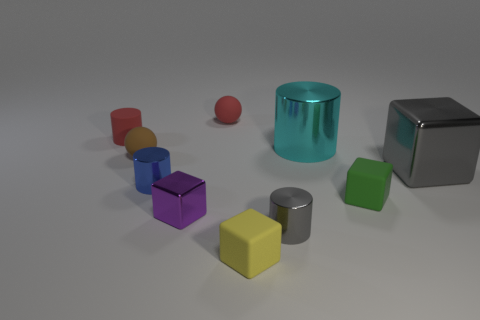Are there any cylinders on the right side of the brown thing?
Your response must be concise. Yes. What is the color of the rubber object that is both in front of the small blue object and behind the purple metal block?
Give a very brief answer. Green. Are there any small cylinders that have the same color as the large shiny cube?
Make the answer very short. Yes. Do the purple cube that is in front of the cyan cylinder and the large thing that is left of the large cube have the same material?
Make the answer very short. Yes. There is a metal block right of the large metallic cylinder; what is its size?
Provide a succinct answer. Large. What is the size of the cyan object?
Your answer should be compact. Large. What size is the gray shiny thing that is left of the gray metal block that is right of the gray metallic object that is left of the large cyan cylinder?
Your answer should be very brief. Small. Are there any tiny blue things made of the same material as the cyan cylinder?
Offer a very short reply. Yes. What is the shape of the yellow thing?
Offer a terse response. Cube. What is the color of the tiny cylinder that is the same material as the blue thing?
Your response must be concise. Gray. 